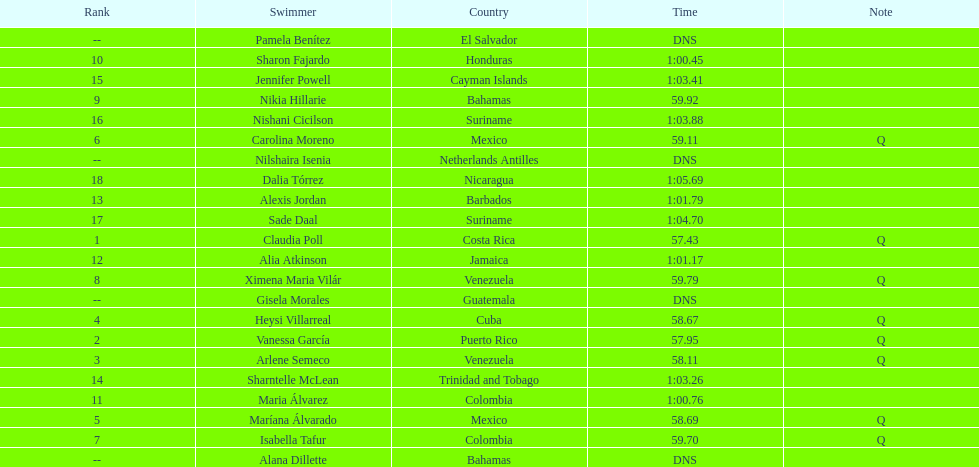Who finished after claudia poll? Vanessa García. 